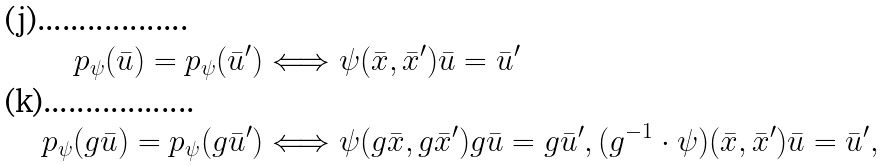Convert formula to latex. <formula><loc_0><loc_0><loc_500><loc_500>p _ { \psi } ( \bar { u } ) = p _ { \psi } ( \bar { u } ^ { \prime } ) & \Longleftrightarrow \psi ( \bar { x } , \bar { x } ^ { \prime } ) \bar { u } = \bar { u } ^ { \prime } \\ p _ { \psi } ( g \bar { u } ) = p _ { \psi } ( g \bar { u } ^ { \prime } ) & \Longleftrightarrow \psi ( g \bar { x } , g \bar { x } ^ { \prime } ) g \bar { u } = g \bar { u } ^ { \prime } , ( g ^ { - 1 } \cdot \psi ) ( \bar { x } , \bar { x } ^ { \prime } ) \bar { u } = \bar { u } ^ { \prime } ,</formula> 